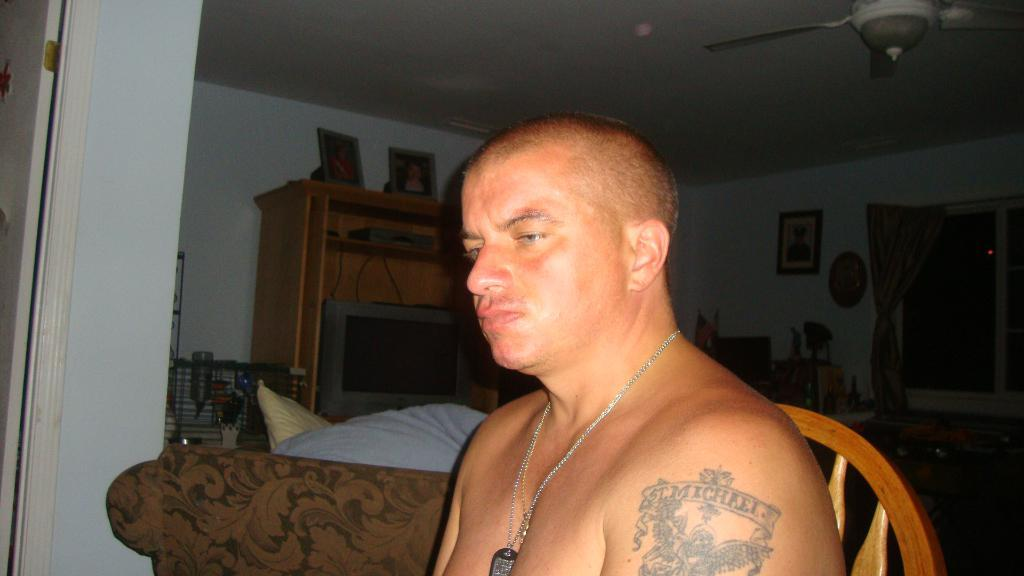What is the man in the image doing? The man is sitting on a chair in the image. What is located behind the man? There is a bed behind the man. What can be found inside the cupboard in the image? There is a TV inside the cupboard in the image. What is hanging on the wall in the image? There are photo frames on the wall in the image. What type of bone can be seen in the image? There is no bone present in the image. How many people are in the group in the image? There is no group of people present in the image; it only features a man sitting on a chair. 